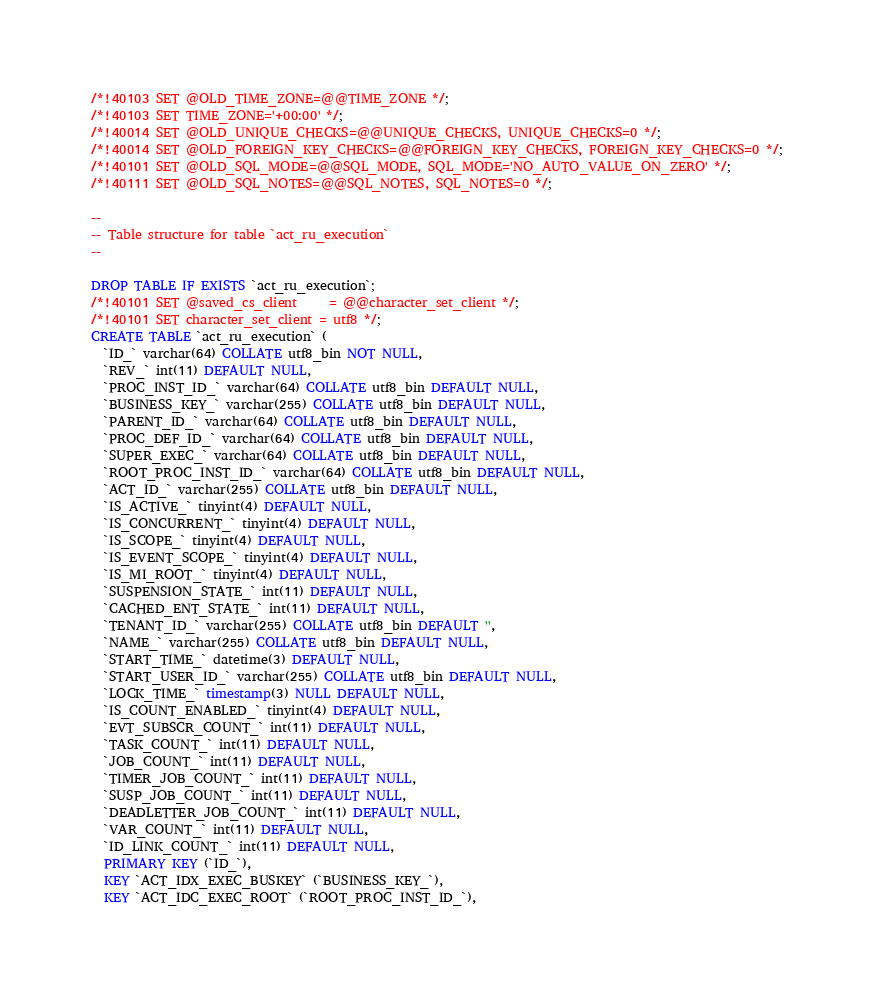Convert code to text. <code><loc_0><loc_0><loc_500><loc_500><_SQL_>/*!40103 SET @OLD_TIME_ZONE=@@TIME_ZONE */;
/*!40103 SET TIME_ZONE='+00:00' */;
/*!40014 SET @OLD_UNIQUE_CHECKS=@@UNIQUE_CHECKS, UNIQUE_CHECKS=0 */;
/*!40014 SET @OLD_FOREIGN_KEY_CHECKS=@@FOREIGN_KEY_CHECKS, FOREIGN_KEY_CHECKS=0 */;
/*!40101 SET @OLD_SQL_MODE=@@SQL_MODE, SQL_MODE='NO_AUTO_VALUE_ON_ZERO' */;
/*!40111 SET @OLD_SQL_NOTES=@@SQL_NOTES, SQL_NOTES=0 */;

--
-- Table structure for table `act_ru_execution`
--

DROP TABLE IF EXISTS `act_ru_execution`;
/*!40101 SET @saved_cs_client     = @@character_set_client */;
/*!40101 SET character_set_client = utf8 */;
CREATE TABLE `act_ru_execution` (
  `ID_` varchar(64) COLLATE utf8_bin NOT NULL,
  `REV_` int(11) DEFAULT NULL,
  `PROC_INST_ID_` varchar(64) COLLATE utf8_bin DEFAULT NULL,
  `BUSINESS_KEY_` varchar(255) COLLATE utf8_bin DEFAULT NULL,
  `PARENT_ID_` varchar(64) COLLATE utf8_bin DEFAULT NULL,
  `PROC_DEF_ID_` varchar(64) COLLATE utf8_bin DEFAULT NULL,
  `SUPER_EXEC_` varchar(64) COLLATE utf8_bin DEFAULT NULL,
  `ROOT_PROC_INST_ID_` varchar(64) COLLATE utf8_bin DEFAULT NULL,
  `ACT_ID_` varchar(255) COLLATE utf8_bin DEFAULT NULL,
  `IS_ACTIVE_` tinyint(4) DEFAULT NULL,
  `IS_CONCURRENT_` tinyint(4) DEFAULT NULL,
  `IS_SCOPE_` tinyint(4) DEFAULT NULL,
  `IS_EVENT_SCOPE_` tinyint(4) DEFAULT NULL,
  `IS_MI_ROOT_` tinyint(4) DEFAULT NULL,
  `SUSPENSION_STATE_` int(11) DEFAULT NULL,
  `CACHED_ENT_STATE_` int(11) DEFAULT NULL,
  `TENANT_ID_` varchar(255) COLLATE utf8_bin DEFAULT '',
  `NAME_` varchar(255) COLLATE utf8_bin DEFAULT NULL,
  `START_TIME_` datetime(3) DEFAULT NULL,
  `START_USER_ID_` varchar(255) COLLATE utf8_bin DEFAULT NULL,
  `LOCK_TIME_` timestamp(3) NULL DEFAULT NULL,
  `IS_COUNT_ENABLED_` tinyint(4) DEFAULT NULL,
  `EVT_SUBSCR_COUNT_` int(11) DEFAULT NULL,
  `TASK_COUNT_` int(11) DEFAULT NULL,
  `JOB_COUNT_` int(11) DEFAULT NULL,
  `TIMER_JOB_COUNT_` int(11) DEFAULT NULL,
  `SUSP_JOB_COUNT_` int(11) DEFAULT NULL,
  `DEADLETTER_JOB_COUNT_` int(11) DEFAULT NULL,
  `VAR_COUNT_` int(11) DEFAULT NULL,
  `ID_LINK_COUNT_` int(11) DEFAULT NULL,
  PRIMARY KEY (`ID_`),
  KEY `ACT_IDX_EXEC_BUSKEY` (`BUSINESS_KEY_`),
  KEY `ACT_IDC_EXEC_ROOT` (`ROOT_PROC_INST_ID_`),</code> 